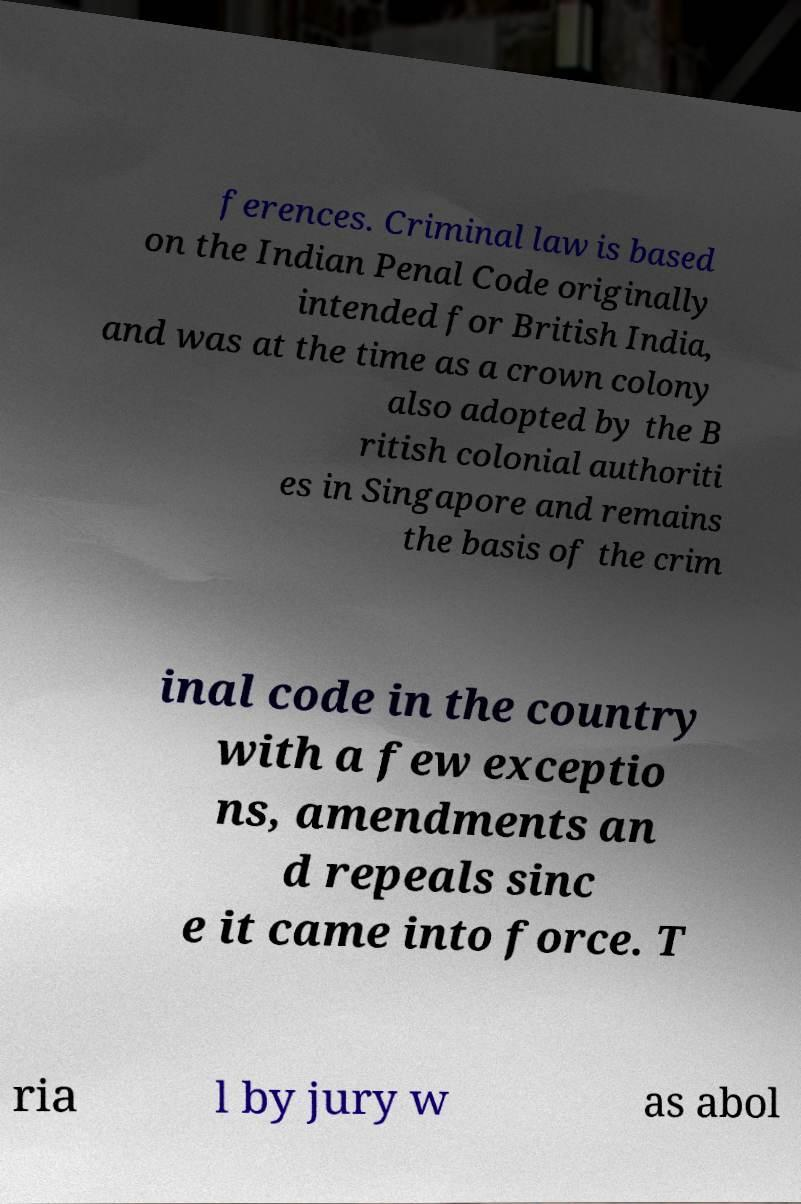Please identify and transcribe the text found in this image. ferences. Criminal law is based on the Indian Penal Code originally intended for British India, and was at the time as a crown colony also adopted by the B ritish colonial authoriti es in Singapore and remains the basis of the crim inal code in the country with a few exceptio ns, amendments an d repeals sinc e it came into force. T ria l by jury w as abol 